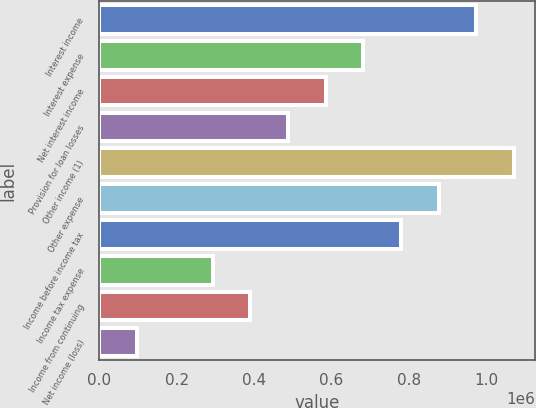<chart> <loc_0><loc_0><loc_500><loc_500><bar_chart><fcel>Interest income<fcel>Interest expense<fcel>Net interest income<fcel>Provision for loan losses<fcel>Other income (1)<fcel>Other expense<fcel>Income before income tax<fcel>Income tax expense<fcel>Income from continuing<fcel>Net income (loss)<nl><fcel>975544<fcel>682881<fcel>585326<fcel>487772<fcel>1.0731e+06<fcel>877990<fcel>780435<fcel>292663<fcel>390218<fcel>97554.6<nl></chart> 